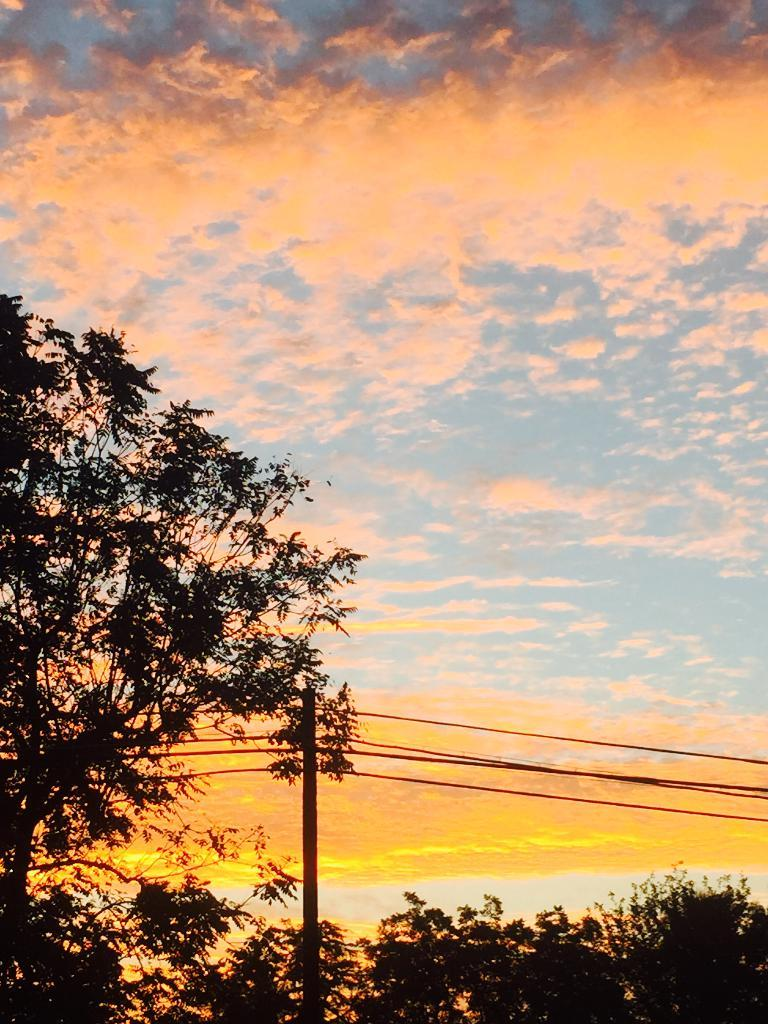What type of vegetation can be seen in the image? There are trees in the image. What man-made structure is present in the image? There is a utility pole in the image. What can be seen in the background of the image? The sky is visible in the background of the image. What type of sign can be seen on the seashore in the image? There is no seashore present in the image, and therefore no sign can be seen on it. What type of cloud is visible in the image? The provided facts do not mention any clouds in the image, so we cannot determine the type of cloud visible. 